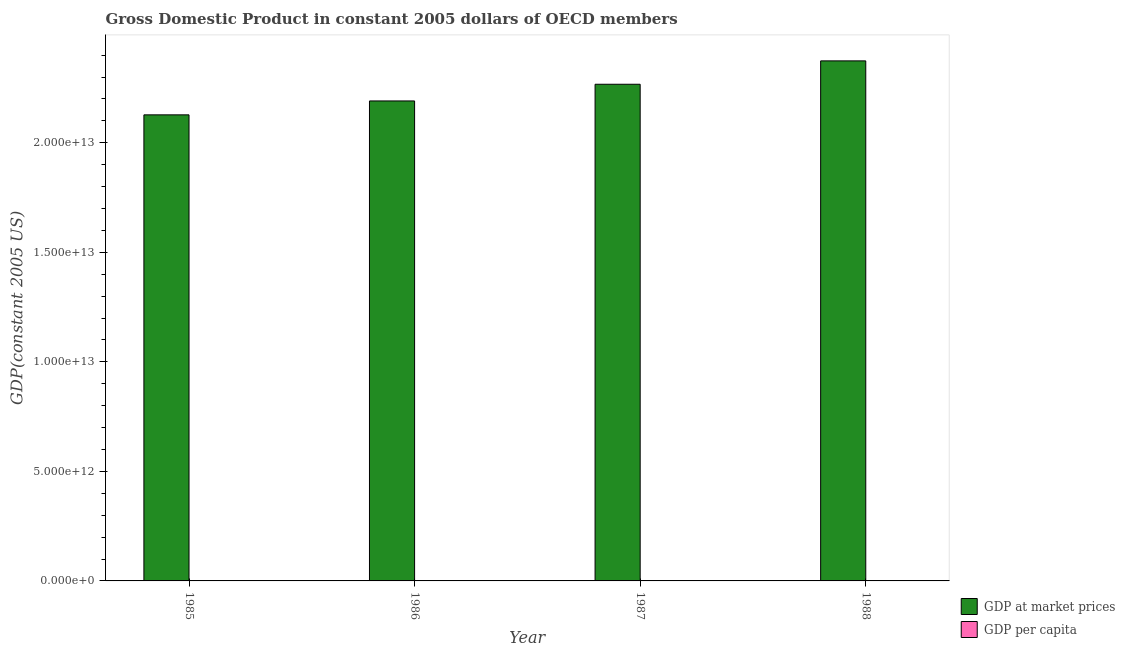Are the number of bars per tick equal to the number of legend labels?
Give a very brief answer. Yes. Are the number of bars on each tick of the X-axis equal?
Your answer should be very brief. Yes. How many bars are there on the 3rd tick from the right?
Make the answer very short. 2. What is the label of the 2nd group of bars from the left?
Make the answer very short. 1986. In how many cases, is the number of bars for a given year not equal to the number of legend labels?
Provide a short and direct response. 0. What is the gdp at market prices in 1986?
Provide a short and direct response. 2.19e+13. Across all years, what is the maximum gdp per capita?
Provide a succinct answer. 2.26e+04. Across all years, what is the minimum gdp per capita?
Provide a short and direct response. 2.08e+04. In which year was the gdp per capita minimum?
Your answer should be compact. 1985. What is the total gdp per capita in the graph?
Keep it short and to the point. 8.64e+04. What is the difference between the gdp at market prices in 1985 and that in 1987?
Make the answer very short. -1.40e+12. What is the difference between the gdp per capita in 1986 and the gdp at market prices in 1985?
Make the answer very short. 455.47. What is the average gdp at market prices per year?
Ensure brevity in your answer.  2.24e+13. What is the ratio of the gdp per capita in 1986 to that in 1987?
Make the answer very short. 0.97. Is the gdp at market prices in 1986 less than that in 1988?
Keep it short and to the point. Yes. What is the difference between the highest and the second highest gdp per capita?
Offer a very short reply. 850.57. What is the difference between the highest and the lowest gdp per capita?
Provide a succinct answer. 1877.54. In how many years, is the gdp at market prices greater than the average gdp at market prices taken over all years?
Your answer should be compact. 2. What does the 1st bar from the left in 1985 represents?
Your answer should be compact. GDP at market prices. What does the 1st bar from the right in 1988 represents?
Provide a succinct answer. GDP per capita. Are all the bars in the graph horizontal?
Your answer should be very brief. No. What is the difference between two consecutive major ticks on the Y-axis?
Keep it short and to the point. 5.00e+12. Are the values on the major ticks of Y-axis written in scientific E-notation?
Make the answer very short. Yes. How are the legend labels stacked?
Keep it short and to the point. Vertical. What is the title of the graph?
Give a very brief answer. Gross Domestic Product in constant 2005 dollars of OECD members. What is the label or title of the Y-axis?
Ensure brevity in your answer.  GDP(constant 2005 US). What is the GDP(constant 2005 US) in GDP at market prices in 1985?
Ensure brevity in your answer.  2.13e+13. What is the GDP(constant 2005 US) in GDP per capita in 1985?
Keep it short and to the point. 2.08e+04. What is the GDP(constant 2005 US) in GDP at market prices in 1986?
Your answer should be compact. 2.19e+13. What is the GDP(constant 2005 US) of GDP per capita in 1986?
Your answer should be compact. 2.12e+04. What is the GDP(constant 2005 US) in GDP at market prices in 1987?
Offer a very short reply. 2.27e+13. What is the GDP(constant 2005 US) of GDP per capita in 1987?
Make the answer very short. 2.18e+04. What is the GDP(constant 2005 US) in GDP at market prices in 1988?
Provide a short and direct response. 2.37e+13. What is the GDP(constant 2005 US) of GDP per capita in 1988?
Provide a succinct answer. 2.26e+04. Across all years, what is the maximum GDP(constant 2005 US) in GDP at market prices?
Your answer should be very brief. 2.37e+13. Across all years, what is the maximum GDP(constant 2005 US) of GDP per capita?
Provide a succinct answer. 2.26e+04. Across all years, what is the minimum GDP(constant 2005 US) of GDP at market prices?
Make the answer very short. 2.13e+13. Across all years, what is the minimum GDP(constant 2005 US) of GDP per capita?
Your answer should be compact. 2.08e+04. What is the total GDP(constant 2005 US) of GDP at market prices in the graph?
Provide a short and direct response. 8.96e+13. What is the total GDP(constant 2005 US) in GDP per capita in the graph?
Your answer should be very brief. 8.64e+04. What is the difference between the GDP(constant 2005 US) in GDP at market prices in 1985 and that in 1986?
Offer a very short reply. -6.35e+11. What is the difference between the GDP(constant 2005 US) of GDP per capita in 1985 and that in 1986?
Provide a short and direct response. -455.47. What is the difference between the GDP(constant 2005 US) of GDP at market prices in 1985 and that in 1987?
Your answer should be very brief. -1.40e+12. What is the difference between the GDP(constant 2005 US) in GDP per capita in 1985 and that in 1987?
Your answer should be very brief. -1026.96. What is the difference between the GDP(constant 2005 US) of GDP at market prices in 1985 and that in 1988?
Ensure brevity in your answer.  -2.46e+12. What is the difference between the GDP(constant 2005 US) in GDP per capita in 1985 and that in 1988?
Your response must be concise. -1877.54. What is the difference between the GDP(constant 2005 US) in GDP at market prices in 1986 and that in 1987?
Give a very brief answer. -7.62e+11. What is the difference between the GDP(constant 2005 US) in GDP per capita in 1986 and that in 1987?
Make the answer very short. -571.49. What is the difference between the GDP(constant 2005 US) of GDP at market prices in 1986 and that in 1988?
Provide a succinct answer. -1.83e+12. What is the difference between the GDP(constant 2005 US) of GDP per capita in 1986 and that in 1988?
Ensure brevity in your answer.  -1422.06. What is the difference between the GDP(constant 2005 US) in GDP at market prices in 1987 and that in 1988?
Offer a terse response. -1.07e+12. What is the difference between the GDP(constant 2005 US) of GDP per capita in 1987 and that in 1988?
Ensure brevity in your answer.  -850.57. What is the difference between the GDP(constant 2005 US) in GDP at market prices in 1985 and the GDP(constant 2005 US) in GDP per capita in 1986?
Make the answer very short. 2.13e+13. What is the difference between the GDP(constant 2005 US) in GDP at market prices in 1985 and the GDP(constant 2005 US) in GDP per capita in 1987?
Offer a very short reply. 2.13e+13. What is the difference between the GDP(constant 2005 US) of GDP at market prices in 1985 and the GDP(constant 2005 US) of GDP per capita in 1988?
Give a very brief answer. 2.13e+13. What is the difference between the GDP(constant 2005 US) of GDP at market prices in 1986 and the GDP(constant 2005 US) of GDP per capita in 1987?
Your answer should be very brief. 2.19e+13. What is the difference between the GDP(constant 2005 US) in GDP at market prices in 1986 and the GDP(constant 2005 US) in GDP per capita in 1988?
Provide a short and direct response. 2.19e+13. What is the difference between the GDP(constant 2005 US) in GDP at market prices in 1987 and the GDP(constant 2005 US) in GDP per capita in 1988?
Provide a succinct answer. 2.27e+13. What is the average GDP(constant 2005 US) of GDP at market prices per year?
Give a very brief answer. 2.24e+13. What is the average GDP(constant 2005 US) in GDP per capita per year?
Your response must be concise. 2.16e+04. In the year 1985, what is the difference between the GDP(constant 2005 US) in GDP at market prices and GDP(constant 2005 US) in GDP per capita?
Your answer should be very brief. 2.13e+13. In the year 1986, what is the difference between the GDP(constant 2005 US) in GDP at market prices and GDP(constant 2005 US) in GDP per capita?
Provide a short and direct response. 2.19e+13. In the year 1987, what is the difference between the GDP(constant 2005 US) of GDP at market prices and GDP(constant 2005 US) of GDP per capita?
Your answer should be very brief. 2.27e+13. In the year 1988, what is the difference between the GDP(constant 2005 US) in GDP at market prices and GDP(constant 2005 US) in GDP per capita?
Offer a terse response. 2.37e+13. What is the ratio of the GDP(constant 2005 US) in GDP at market prices in 1985 to that in 1986?
Make the answer very short. 0.97. What is the ratio of the GDP(constant 2005 US) of GDP per capita in 1985 to that in 1986?
Your answer should be compact. 0.98. What is the ratio of the GDP(constant 2005 US) of GDP at market prices in 1985 to that in 1987?
Your answer should be very brief. 0.94. What is the ratio of the GDP(constant 2005 US) of GDP per capita in 1985 to that in 1987?
Provide a short and direct response. 0.95. What is the ratio of the GDP(constant 2005 US) of GDP at market prices in 1985 to that in 1988?
Offer a very short reply. 0.9. What is the ratio of the GDP(constant 2005 US) of GDP per capita in 1985 to that in 1988?
Your answer should be compact. 0.92. What is the ratio of the GDP(constant 2005 US) in GDP at market prices in 1986 to that in 1987?
Keep it short and to the point. 0.97. What is the ratio of the GDP(constant 2005 US) in GDP per capita in 1986 to that in 1987?
Provide a short and direct response. 0.97. What is the ratio of the GDP(constant 2005 US) in GDP at market prices in 1986 to that in 1988?
Keep it short and to the point. 0.92. What is the ratio of the GDP(constant 2005 US) of GDP per capita in 1986 to that in 1988?
Provide a succinct answer. 0.94. What is the ratio of the GDP(constant 2005 US) in GDP at market prices in 1987 to that in 1988?
Offer a terse response. 0.95. What is the ratio of the GDP(constant 2005 US) of GDP per capita in 1987 to that in 1988?
Your answer should be very brief. 0.96. What is the difference between the highest and the second highest GDP(constant 2005 US) in GDP at market prices?
Your answer should be compact. 1.07e+12. What is the difference between the highest and the second highest GDP(constant 2005 US) in GDP per capita?
Provide a short and direct response. 850.57. What is the difference between the highest and the lowest GDP(constant 2005 US) in GDP at market prices?
Give a very brief answer. 2.46e+12. What is the difference between the highest and the lowest GDP(constant 2005 US) in GDP per capita?
Make the answer very short. 1877.54. 